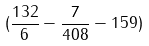<formula> <loc_0><loc_0><loc_500><loc_500>( \frac { 1 3 2 } { 6 } - \frac { 7 } { 4 0 8 } - 1 5 9 )</formula> 